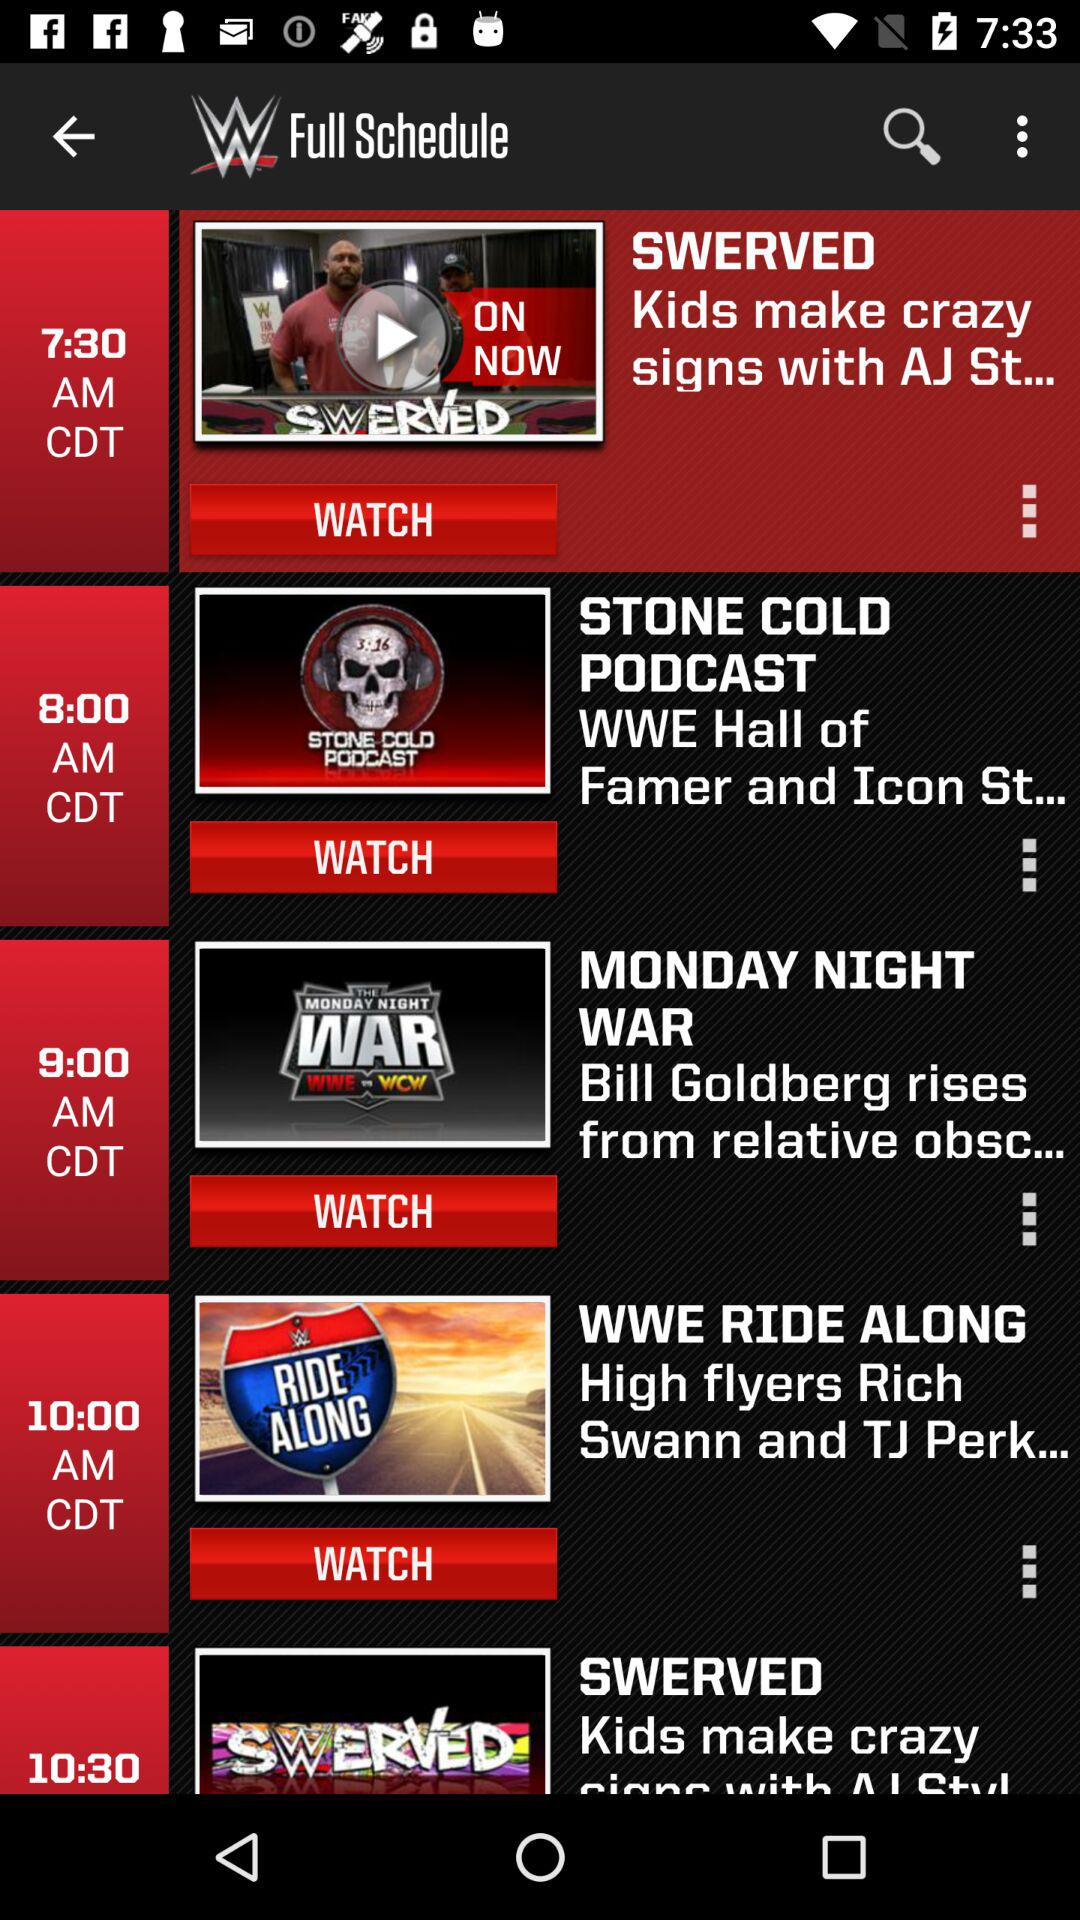At what time does the "STONE COLD PODCAST" air? The "STONE COLD PODCAST" airs at 8:00 a.m. in Central Daylight Time. 